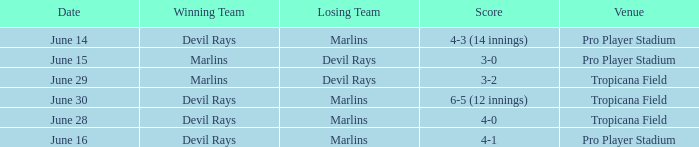What was the score on june 16? 4-1. 